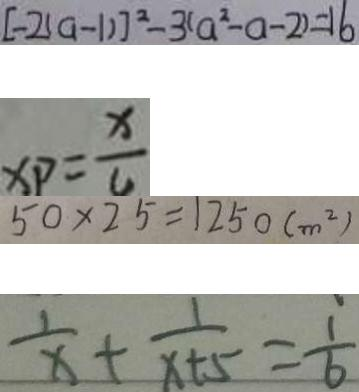Convert formula to latex. <formula><loc_0><loc_0><loc_500><loc_500>[ - 2 ( a - 1 ) ] ^ { 2 } - 3 ( a ^ { 2 } - a - 2 ) = 1 6 
 x p = \frac { x } { 4 } 
 5 0 \times 2 5 = 1 2 5 0 ( m ^ { 2 } ) 
 \frac { 1 } { x } + \frac { 1 } { x + 5 } = \frac { 1 } { 6 }</formula> 